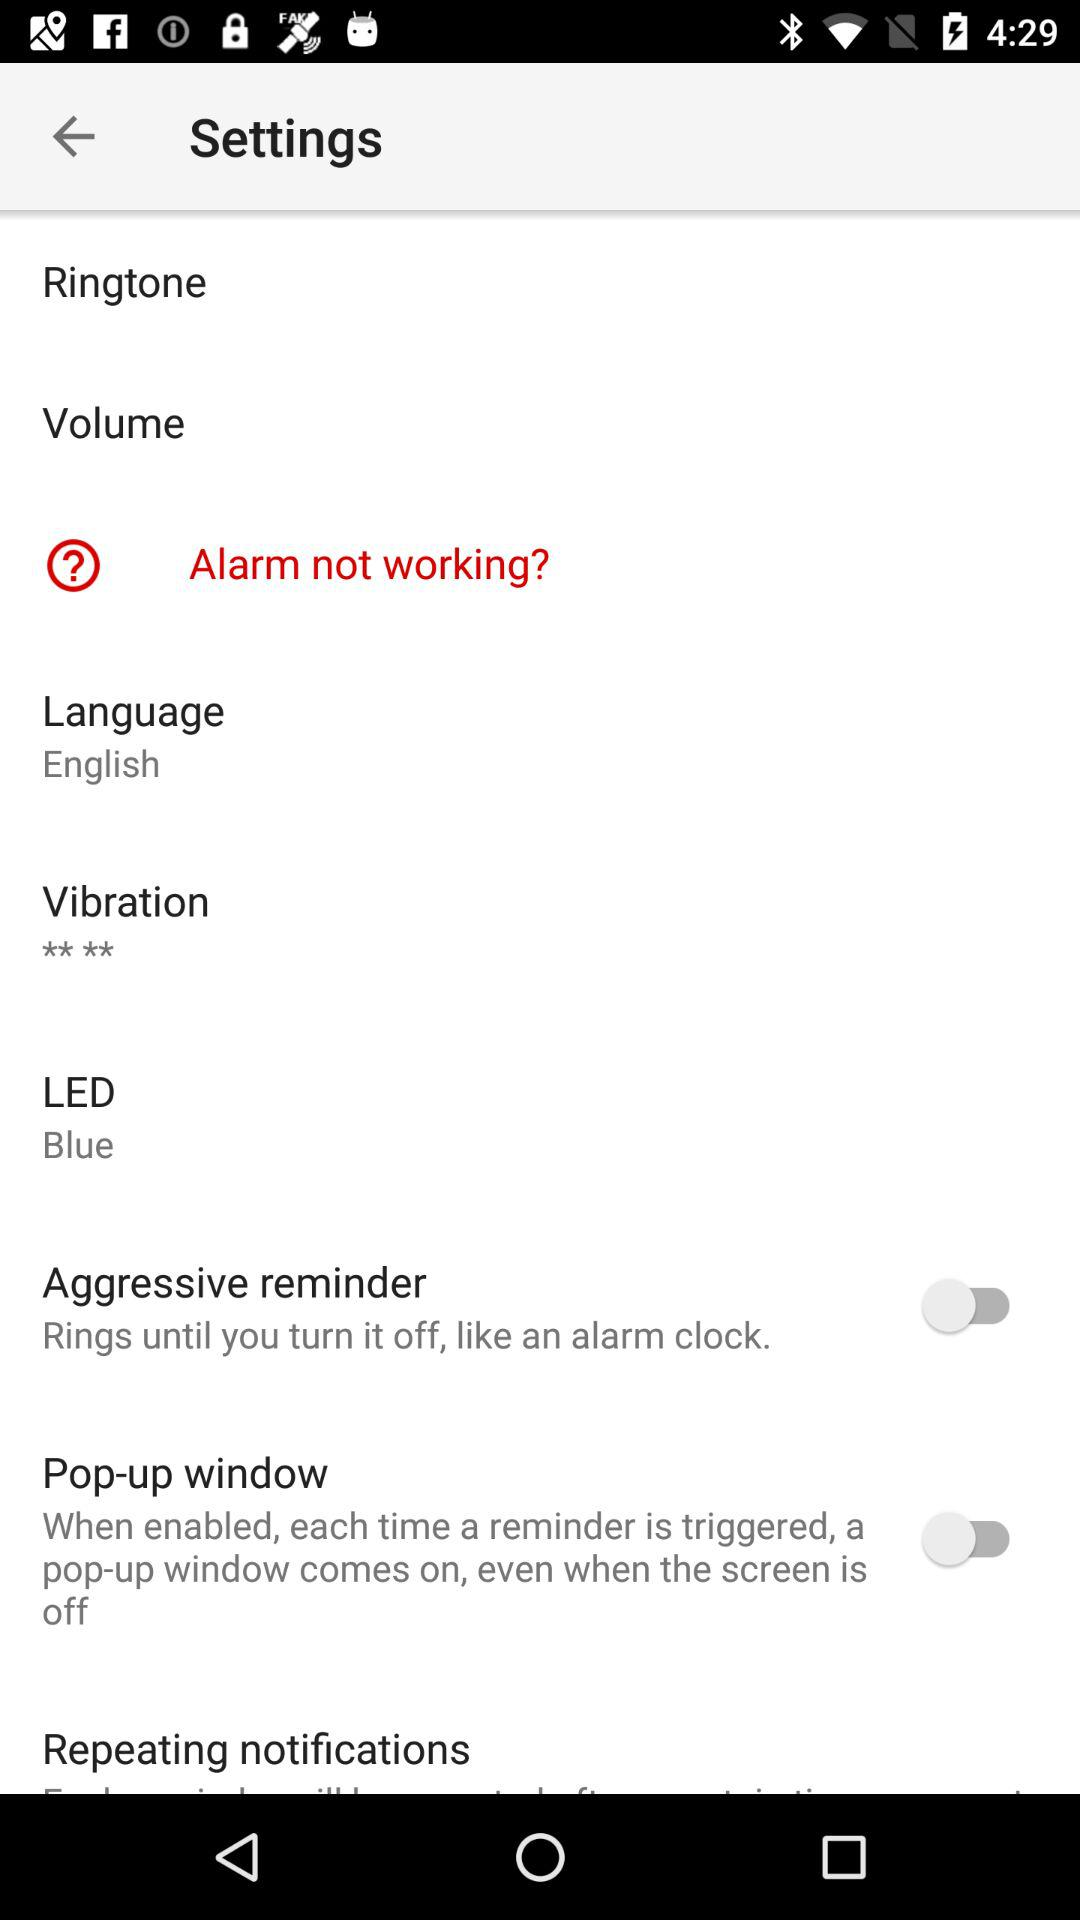What is the status of "Aggressive reminder"? The status of "Aggressive reminder" is off. 